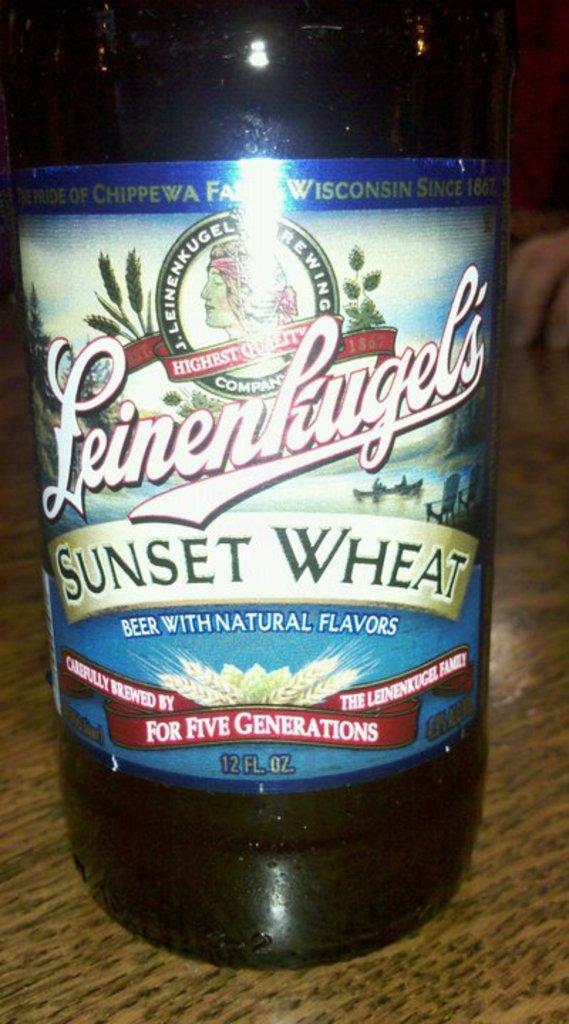What is the beer's name?
Offer a very short reply. Sunset wheat. 